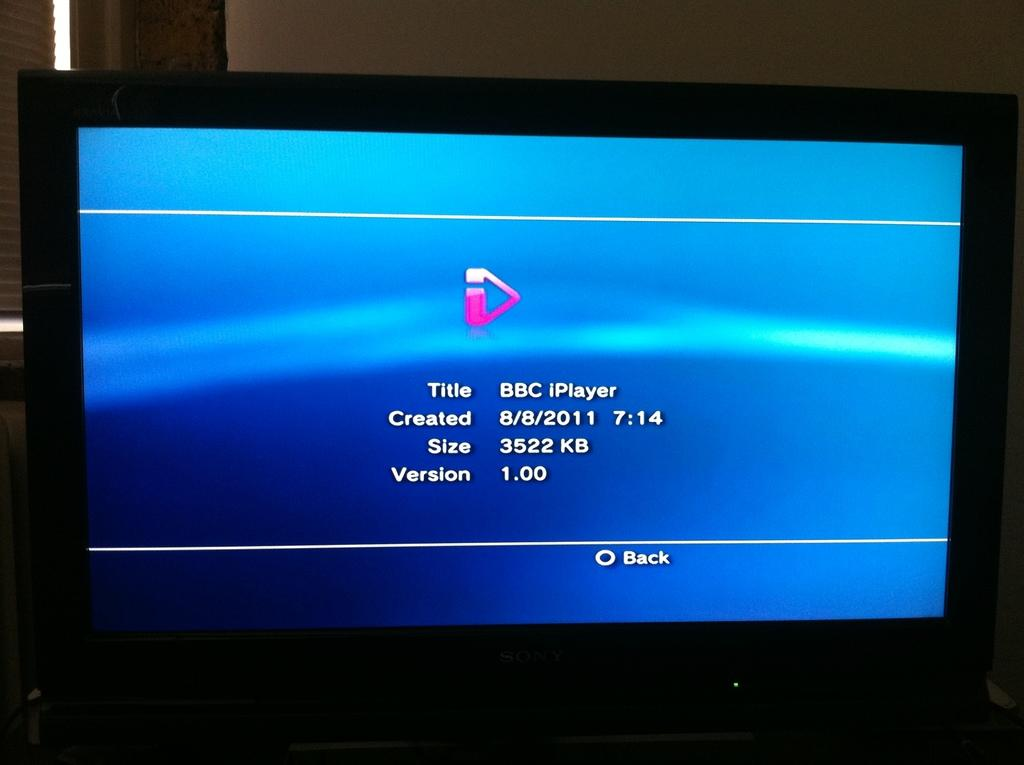<image>
Write a terse but informative summary of the picture. A screen showing the title bbc iplay that was created on 8/8/2011. 